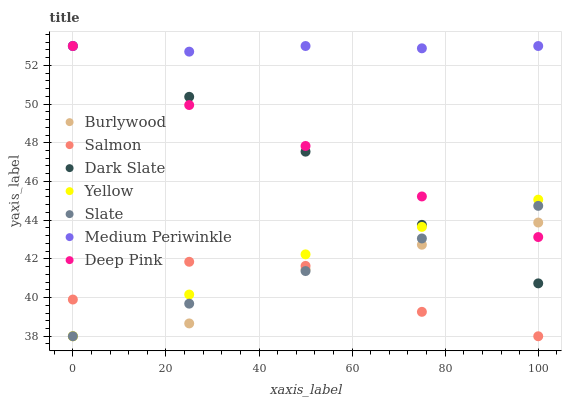Does Salmon have the minimum area under the curve?
Answer yes or no. Yes. Does Medium Periwinkle have the maximum area under the curve?
Answer yes or no. Yes. Does Burlywood have the minimum area under the curve?
Answer yes or no. No. Does Burlywood have the maximum area under the curve?
Answer yes or no. No. Is Slate the smoothest?
Answer yes or no. Yes. Is Salmon the roughest?
Answer yes or no. Yes. Is Burlywood the smoothest?
Answer yes or no. No. Is Burlywood the roughest?
Answer yes or no. No. Does Burlywood have the lowest value?
Answer yes or no. Yes. Does Medium Periwinkle have the lowest value?
Answer yes or no. No. Does Dark Slate have the highest value?
Answer yes or no. Yes. Does Burlywood have the highest value?
Answer yes or no. No. Is Burlywood less than Medium Periwinkle?
Answer yes or no. Yes. Is Medium Periwinkle greater than Salmon?
Answer yes or no. Yes. Does Slate intersect Salmon?
Answer yes or no. Yes. Is Slate less than Salmon?
Answer yes or no. No. Is Slate greater than Salmon?
Answer yes or no. No. Does Burlywood intersect Medium Periwinkle?
Answer yes or no. No. 